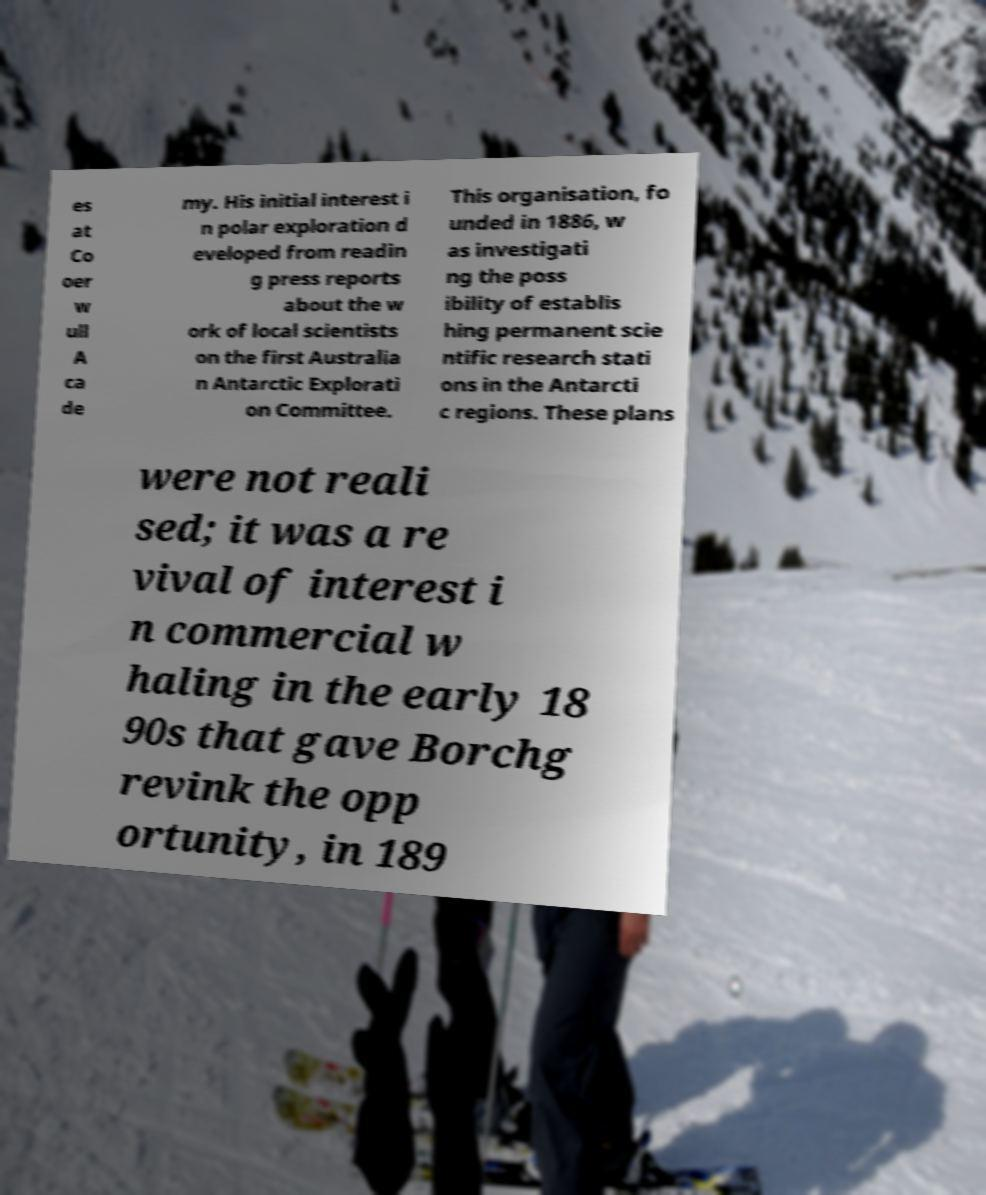Can you accurately transcribe the text from the provided image for me? es at Co oer w ull A ca de my. His initial interest i n polar exploration d eveloped from readin g press reports about the w ork of local scientists on the first Australia n Antarctic Explorati on Committee. This organisation, fo unded in 1886, w as investigati ng the poss ibility of establis hing permanent scie ntific research stati ons in the Antarcti c regions. These plans were not reali sed; it was a re vival of interest i n commercial w haling in the early 18 90s that gave Borchg revink the opp ortunity, in 189 